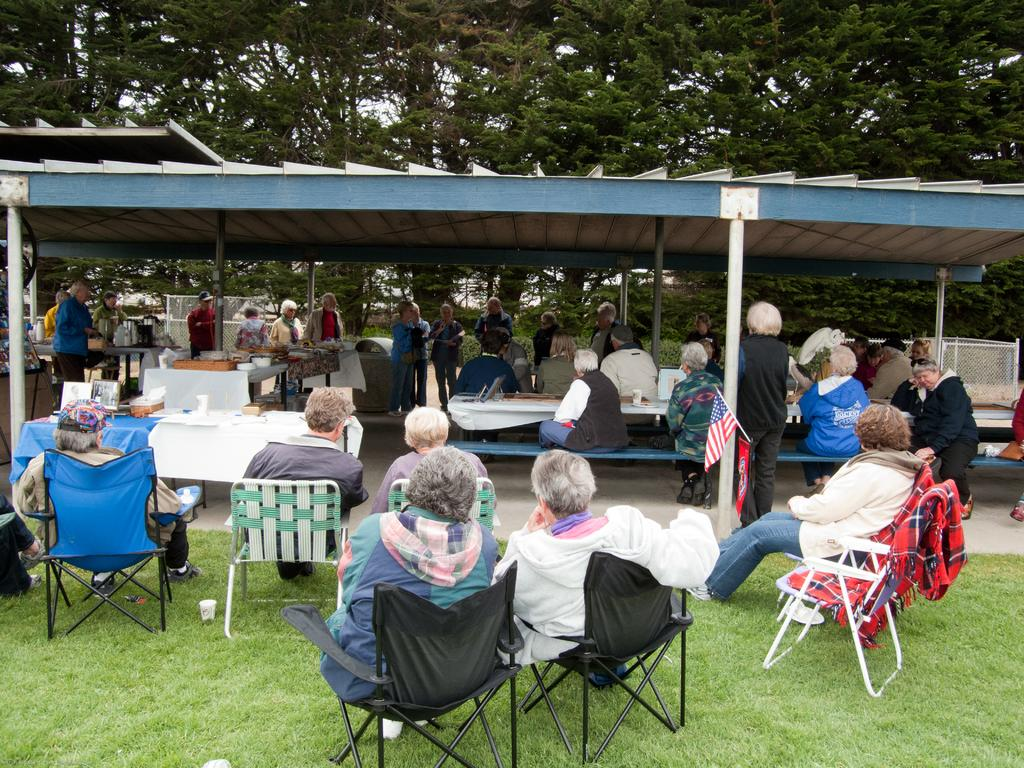How many people are in the image? There is a group of people in the image. What are the people doing in the image? The people are sitting on chairs. What is on the table in the image? There is a plate and a photo frame on the table. What can be seen in the background of the image? The background of the image includes trees. Where is the hydrant located in the image? There is no hydrant present in the image. What historical event is being discussed by the people in the image? The image does not provide any information about a historical event being discussed. 